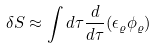Convert formula to latex. <formula><loc_0><loc_0><loc_500><loc_500>\delta S \approx \int d \tau \frac { d } { d \tau } ( \epsilon _ { \varrho } \phi _ { \varrho } )</formula> 